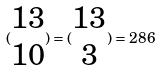Convert formula to latex. <formula><loc_0><loc_0><loc_500><loc_500>( \begin{matrix} 1 3 \\ 1 0 \end{matrix} ) = ( \begin{matrix} 1 3 \\ 3 \end{matrix} ) = 2 8 6</formula> 